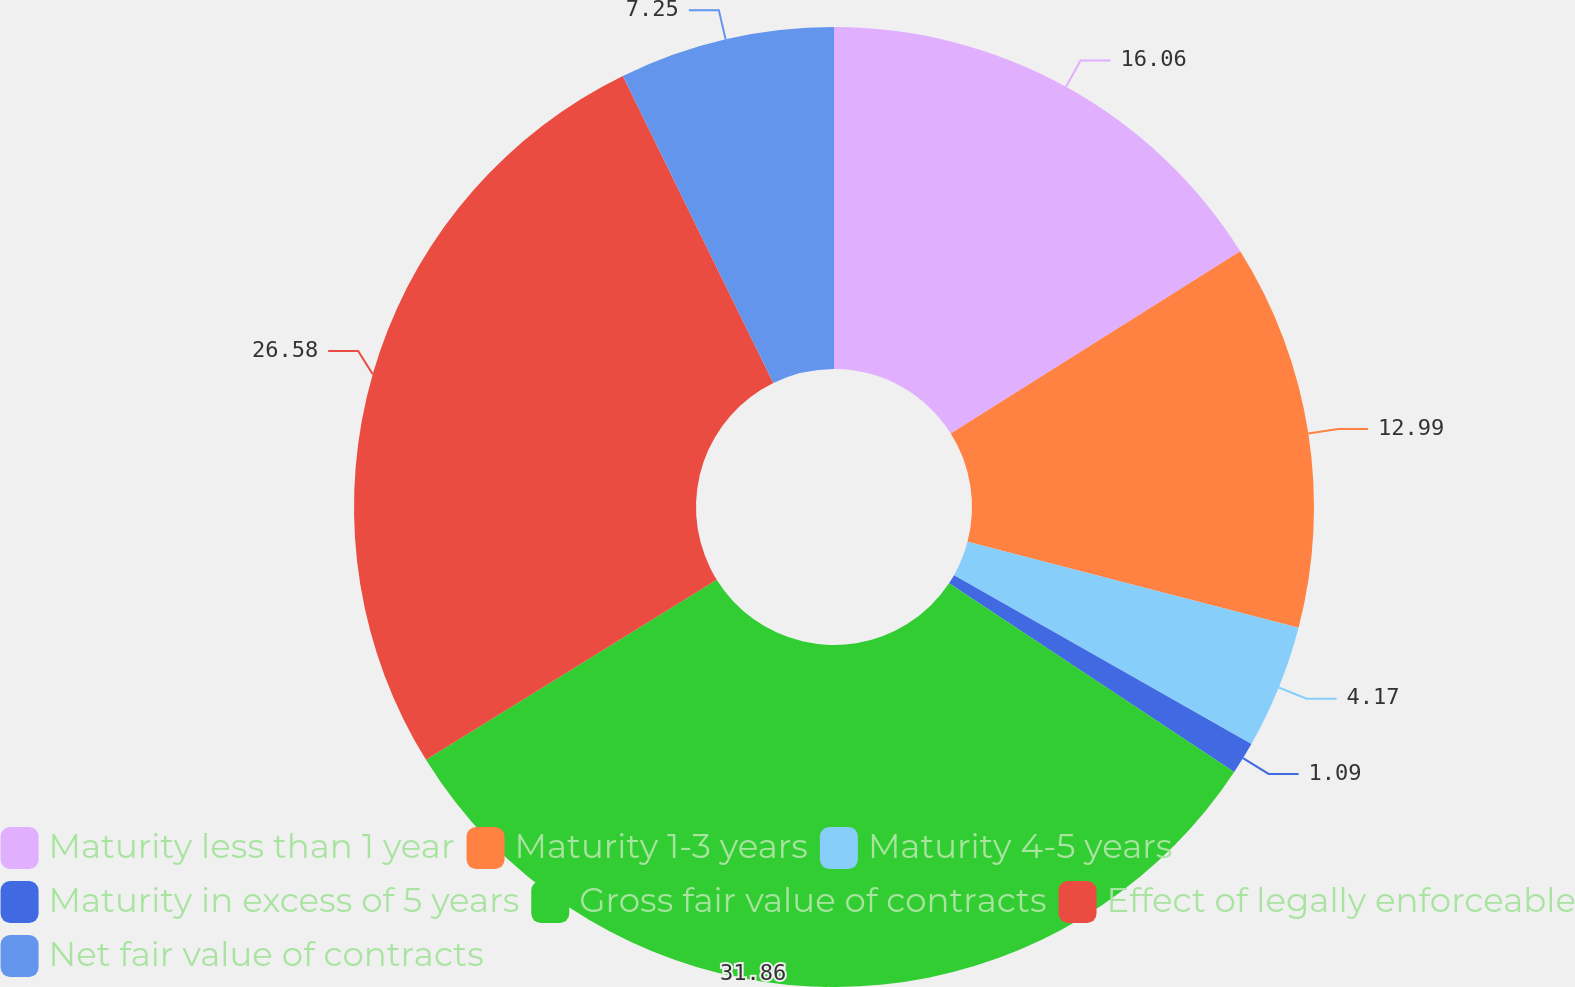Convert chart to OTSL. <chart><loc_0><loc_0><loc_500><loc_500><pie_chart><fcel>Maturity less than 1 year<fcel>Maturity 1-3 years<fcel>Maturity 4-5 years<fcel>Maturity in excess of 5 years<fcel>Gross fair value of contracts<fcel>Effect of legally enforceable<fcel>Net fair value of contracts<nl><fcel>16.06%<fcel>12.99%<fcel>4.17%<fcel>1.09%<fcel>31.86%<fcel>26.58%<fcel>7.25%<nl></chart> 